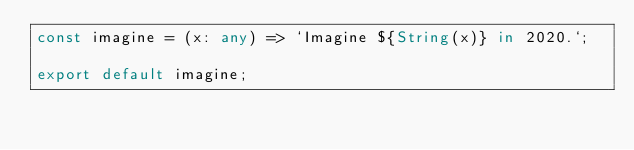<code> <loc_0><loc_0><loc_500><loc_500><_TypeScript_>const imagine = (x: any) => `Imagine ${String(x)} in 2020.`;

export default imagine;
</code> 